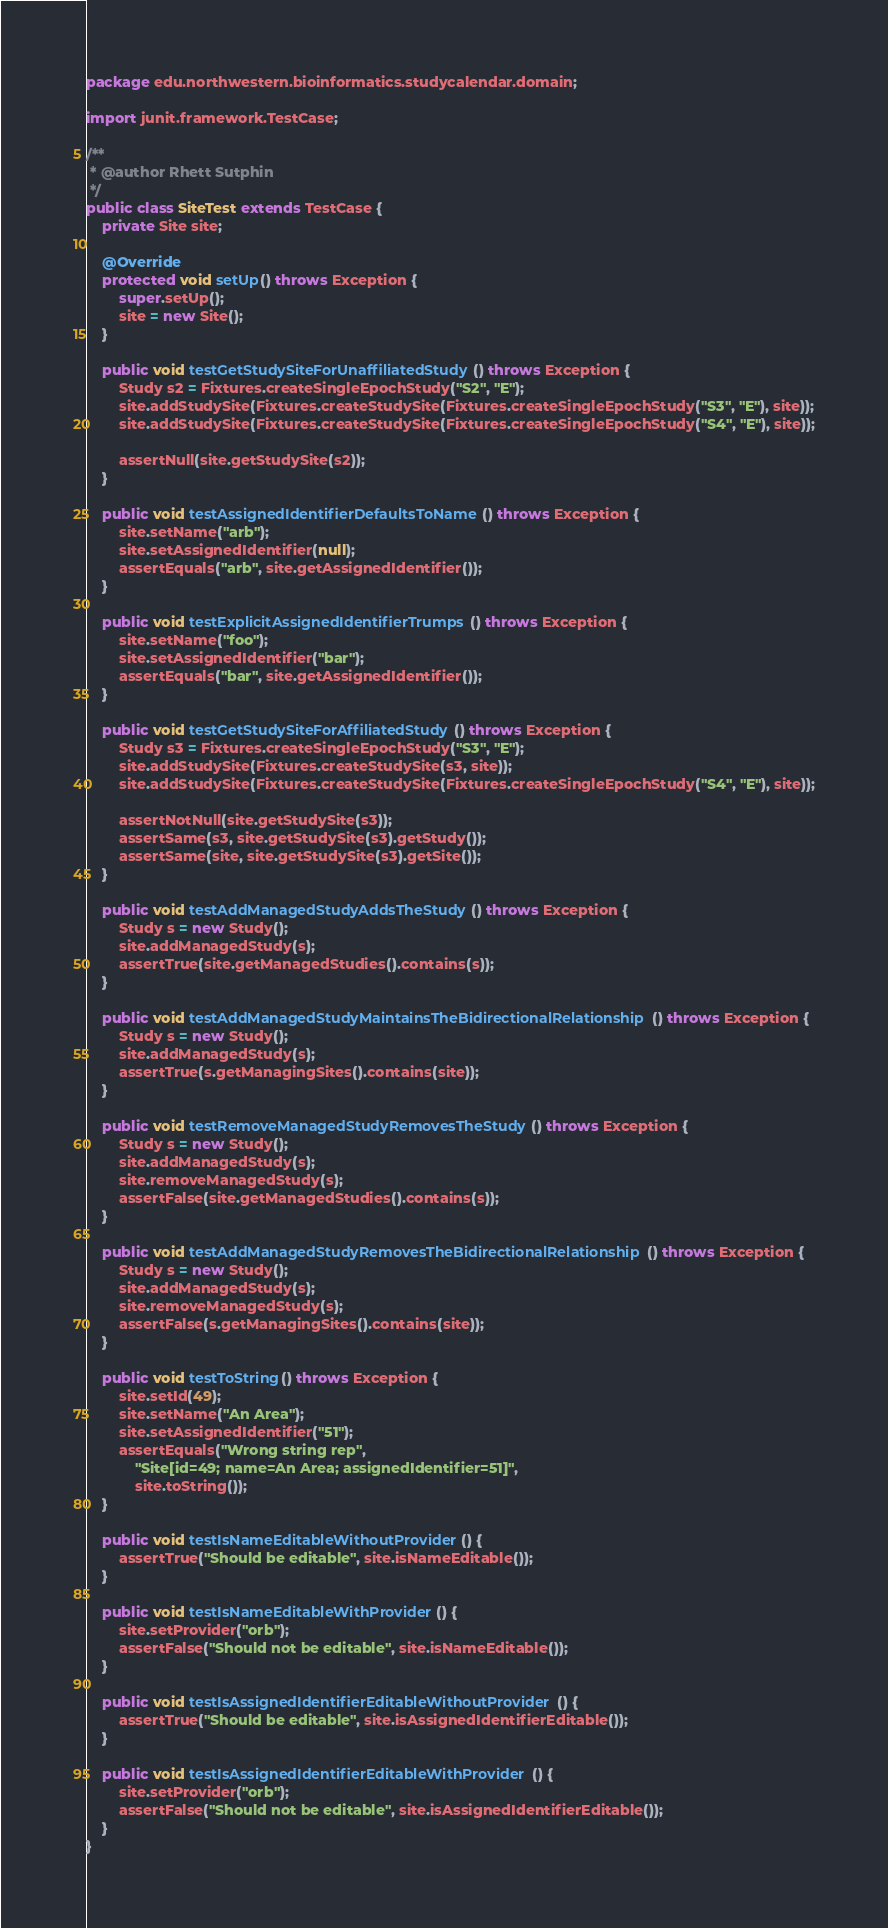<code> <loc_0><loc_0><loc_500><loc_500><_Java_>package edu.northwestern.bioinformatics.studycalendar.domain;

import junit.framework.TestCase;

/**
 * @author Rhett Sutphin
 */
public class SiteTest extends TestCase {
    private Site site;

    @Override
    protected void setUp() throws Exception {
        super.setUp();
        site = new Site();
    }

    public void testGetStudySiteForUnaffiliatedStudy() throws Exception {
        Study s2 = Fixtures.createSingleEpochStudy("S2", "E");
        site.addStudySite(Fixtures.createStudySite(Fixtures.createSingleEpochStudy("S3", "E"), site));
        site.addStudySite(Fixtures.createStudySite(Fixtures.createSingleEpochStudy("S4", "E"), site));

        assertNull(site.getStudySite(s2));
    }

    public void testAssignedIdentifierDefaultsToName() throws Exception {
        site.setName("arb");
        site.setAssignedIdentifier(null);
        assertEquals("arb", site.getAssignedIdentifier());
    }

    public void testExplicitAssignedIdentifierTrumps() throws Exception {
        site.setName("foo");
        site.setAssignedIdentifier("bar");
        assertEquals("bar", site.getAssignedIdentifier());
    }
    
    public void testGetStudySiteForAffiliatedStudy() throws Exception {
        Study s3 = Fixtures.createSingleEpochStudy("S3", "E");
        site.addStudySite(Fixtures.createStudySite(s3, site));
        site.addStudySite(Fixtures.createStudySite(Fixtures.createSingleEpochStudy("S4", "E"), site));

        assertNotNull(site.getStudySite(s3));
        assertSame(s3, site.getStudySite(s3).getStudy());
        assertSame(site, site.getStudySite(s3).getSite());
    }
    
    public void testAddManagedStudyAddsTheStudy() throws Exception {
        Study s = new Study();
        site.addManagedStudy(s);
        assertTrue(site.getManagedStudies().contains(s));
    }

    public void testAddManagedStudyMaintainsTheBidirectionalRelationship() throws Exception {
        Study s = new Study();
        site.addManagedStudy(s);
        assertTrue(s.getManagingSites().contains(site));
    }

    public void testRemoveManagedStudyRemovesTheStudy() throws Exception {
        Study s = new Study();
        site.addManagedStudy(s);
        site.removeManagedStudy(s);
        assertFalse(site.getManagedStudies().contains(s));
    }

    public void testAddManagedStudyRemovesTheBidirectionalRelationship() throws Exception {
        Study s = new Study();
        site.addManagedStudy(s);
        site.removeManagedStudy(s);
        assertFalse(s.getManagingSites().contains(site));
    }

    public void testToString() throws Exception {
        site.setId(49);
        site.setName("An Area");
        site.setAssignedIdentifier("51");
        assertEquals("Wrong string rep",
            "Site[id=49; name=An Area; assignedIdentifier=51]",
            site.toString());
    }

    public void testIsNameEditableWithoutProvider() {
        assertTrue("Should be editable", site.isNameEditable());
    }

    public void testIsNameEditableWithProvider() {
        site.setProvider("orb");
        assertFalse("Should not be editable", site.isNameEditable());
    }

    public void testIsAssignedIdentifierEditableWithoutProvider() {
        assertTrue("Should be editable", site.isAssignedIdentifierEditable());
    }   

    public void testIsAssignedIdentifierEditableWithProvider() {
        site.setProvider("orb");
        assertFalse("Should not be editable", site.isAssignedIdentifierEditable());
    }
}
</code> 